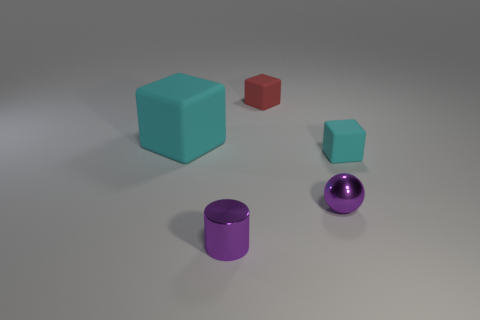There is a metal thing to the right of the red cube; is its color the same as the tiny cube in front of the tiny red matte cube?
Your answer should be compact. No. What number of tiny objects are behind the small purple sphere and right of the red cube?
Provide a succinct answer. 1. What is the red thing made of?
Your answer should be very brief. Rubber. What shape is the cyan matte object that is the same size as the purple sphere?
Offer a terse response. Cube. Do the tiny cube in front of the red object and the cyan cube that is to the left of the red rubber cube have the same material?
Keep it short and to the point. Yes. What number of large cyan things are there?
Your response must be concise. 1. How many small things are the same shape as the large cyan thing?
Your answer should be very brief. 2. Is the shape of the red rubber thing the same as the big cyan rubber object?
Offer a terse response. Yes. What number of cyan things have the same size as the ball?
Keep it short and to the point. 1. There is a cyan matte cube in front of the large matte thing; is it the same size as the cyan cube that is left of the purple ball?
Make the answer very short. No. 